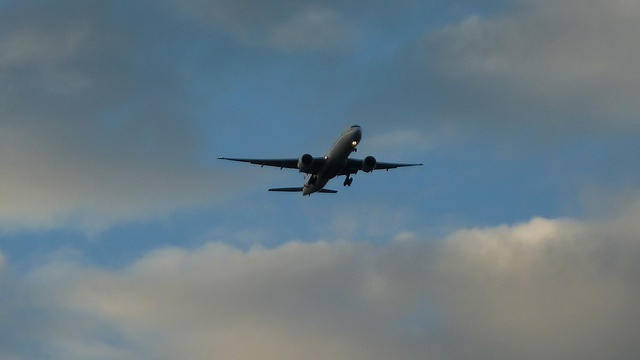Describe the objects in this image and their specific colors. I can see a airplane in gray, black, and blue tones in this image. 